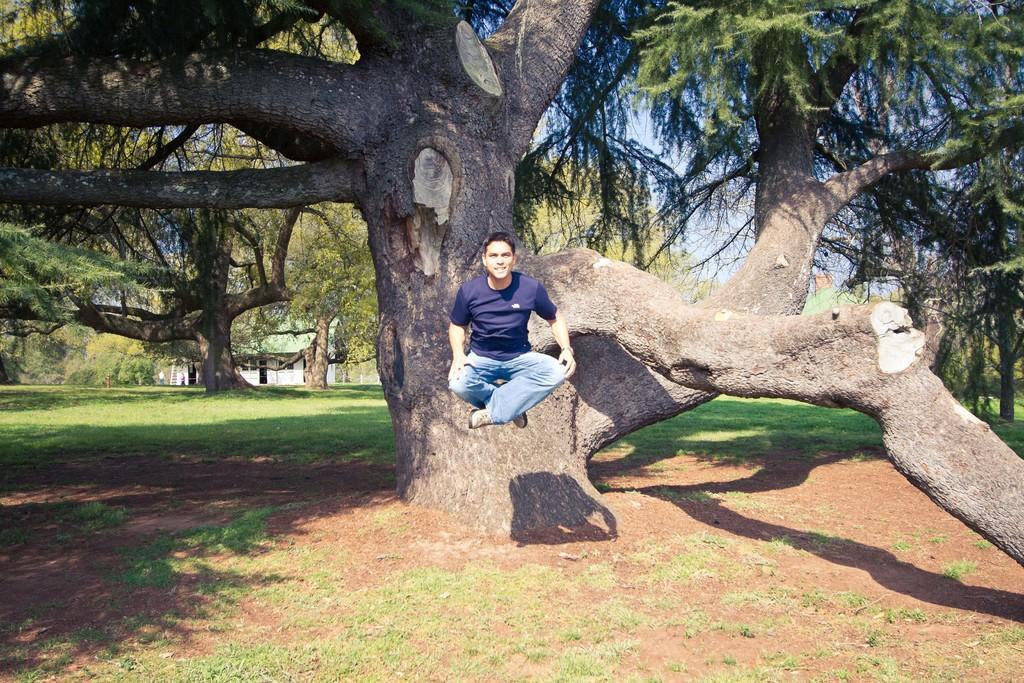Can you describe this image briefly? In this image we can see a person jumping and there are few trees, building and the sky in the background. 